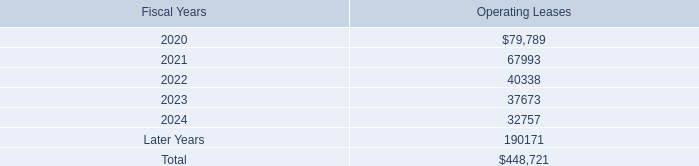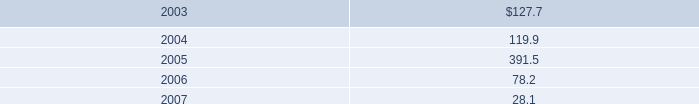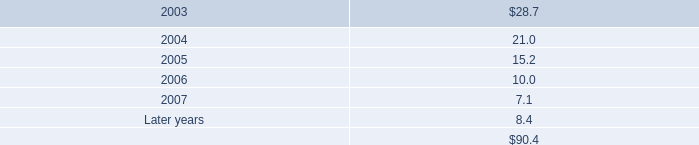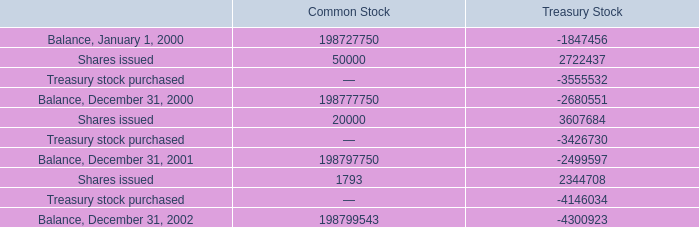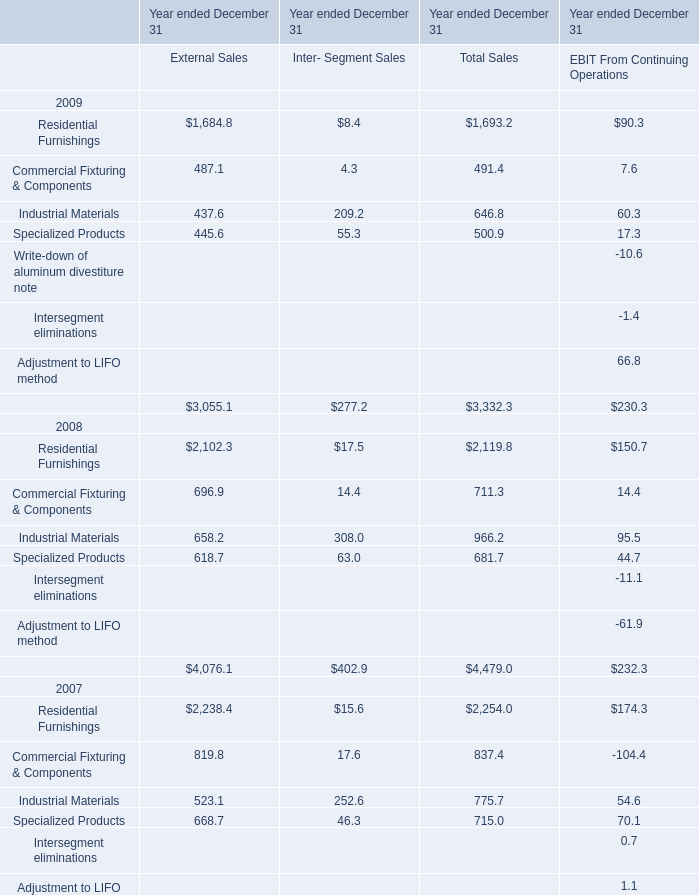what is the percentage change in total rental expense under operating leases in 2019 compare to 2018? 
Computations: ((92.3 - 84.9) / 84.9)
Answer: 0.08716. 